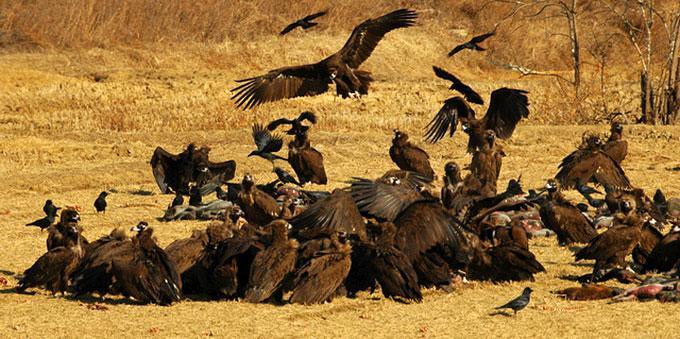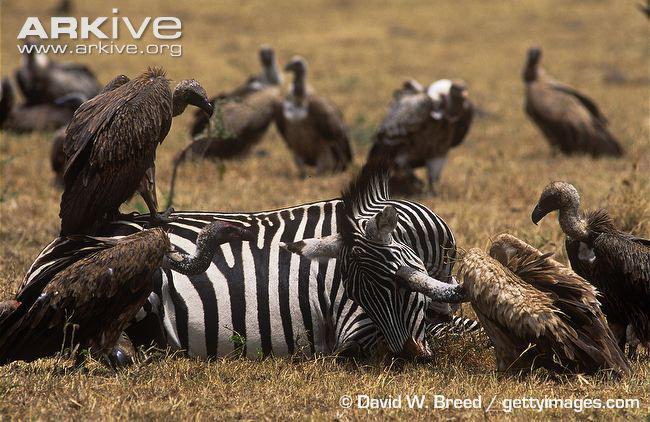The first image is the image on the left, the second image is the image on the right. Given the left and right images, does the statement "It does not appear as though our fine feathered friends are eating right now." hold true? Answer yes or no. No. 